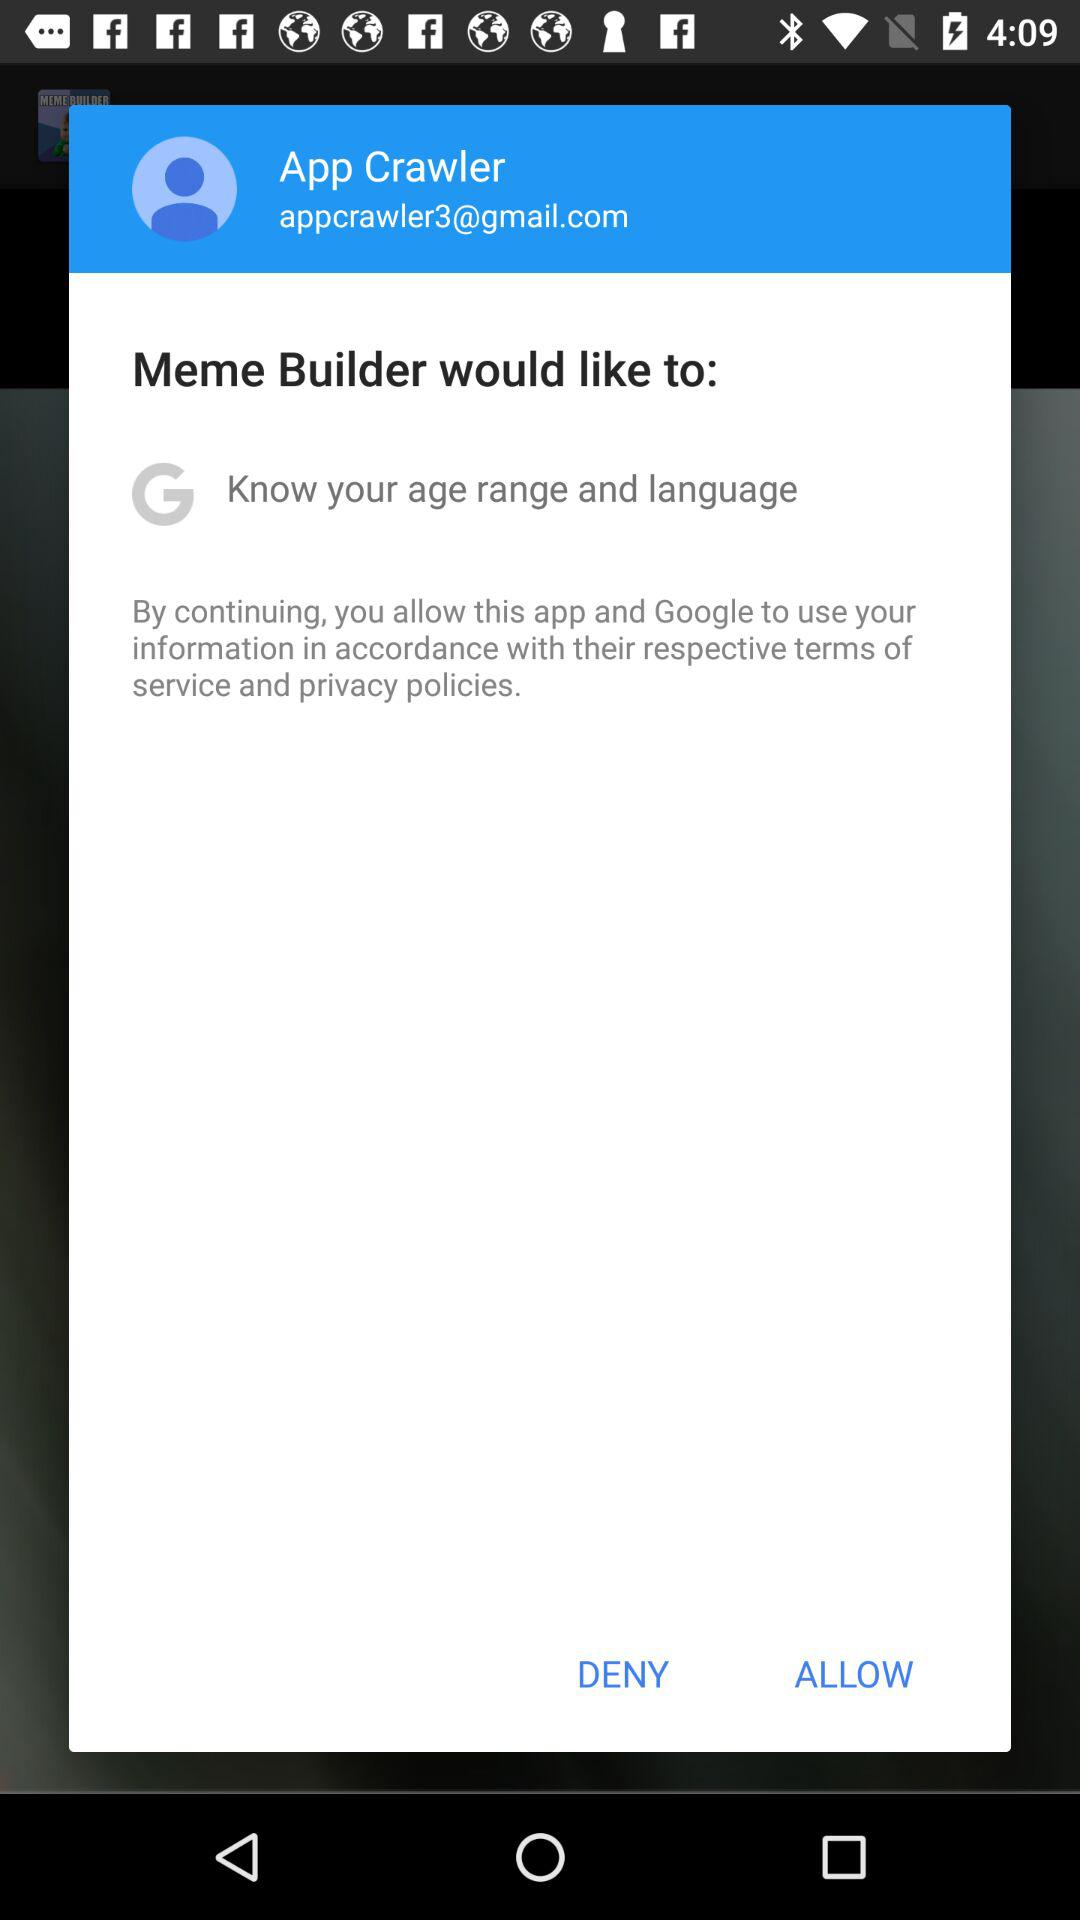What is the user name? The user name is App Crawler. 